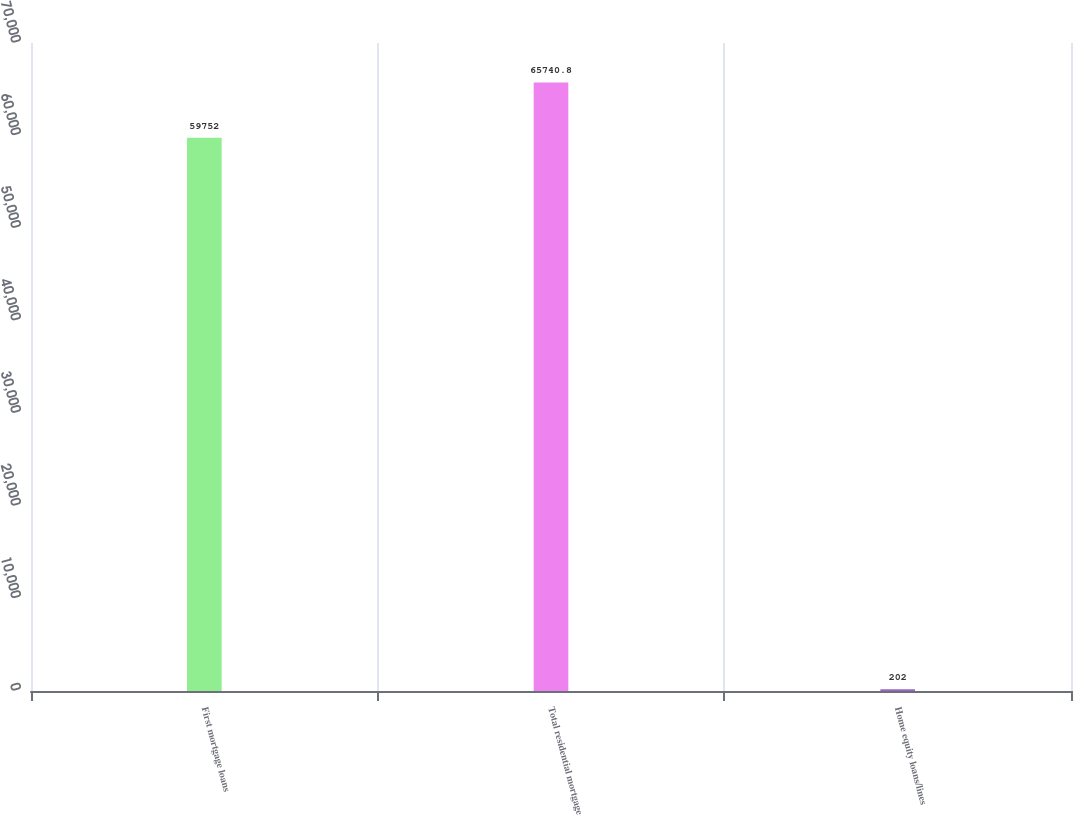Convert chart to OTSL. <chart><loc_0><loc_0><loc_500><loc_500><bar_chart><fcel>First mortgage loans<fcel>Total residential mortgage<fcel>Home equity loans/lines<nl><fcel>59752<fcel>65740.8<fcel>202<nl></chart> 